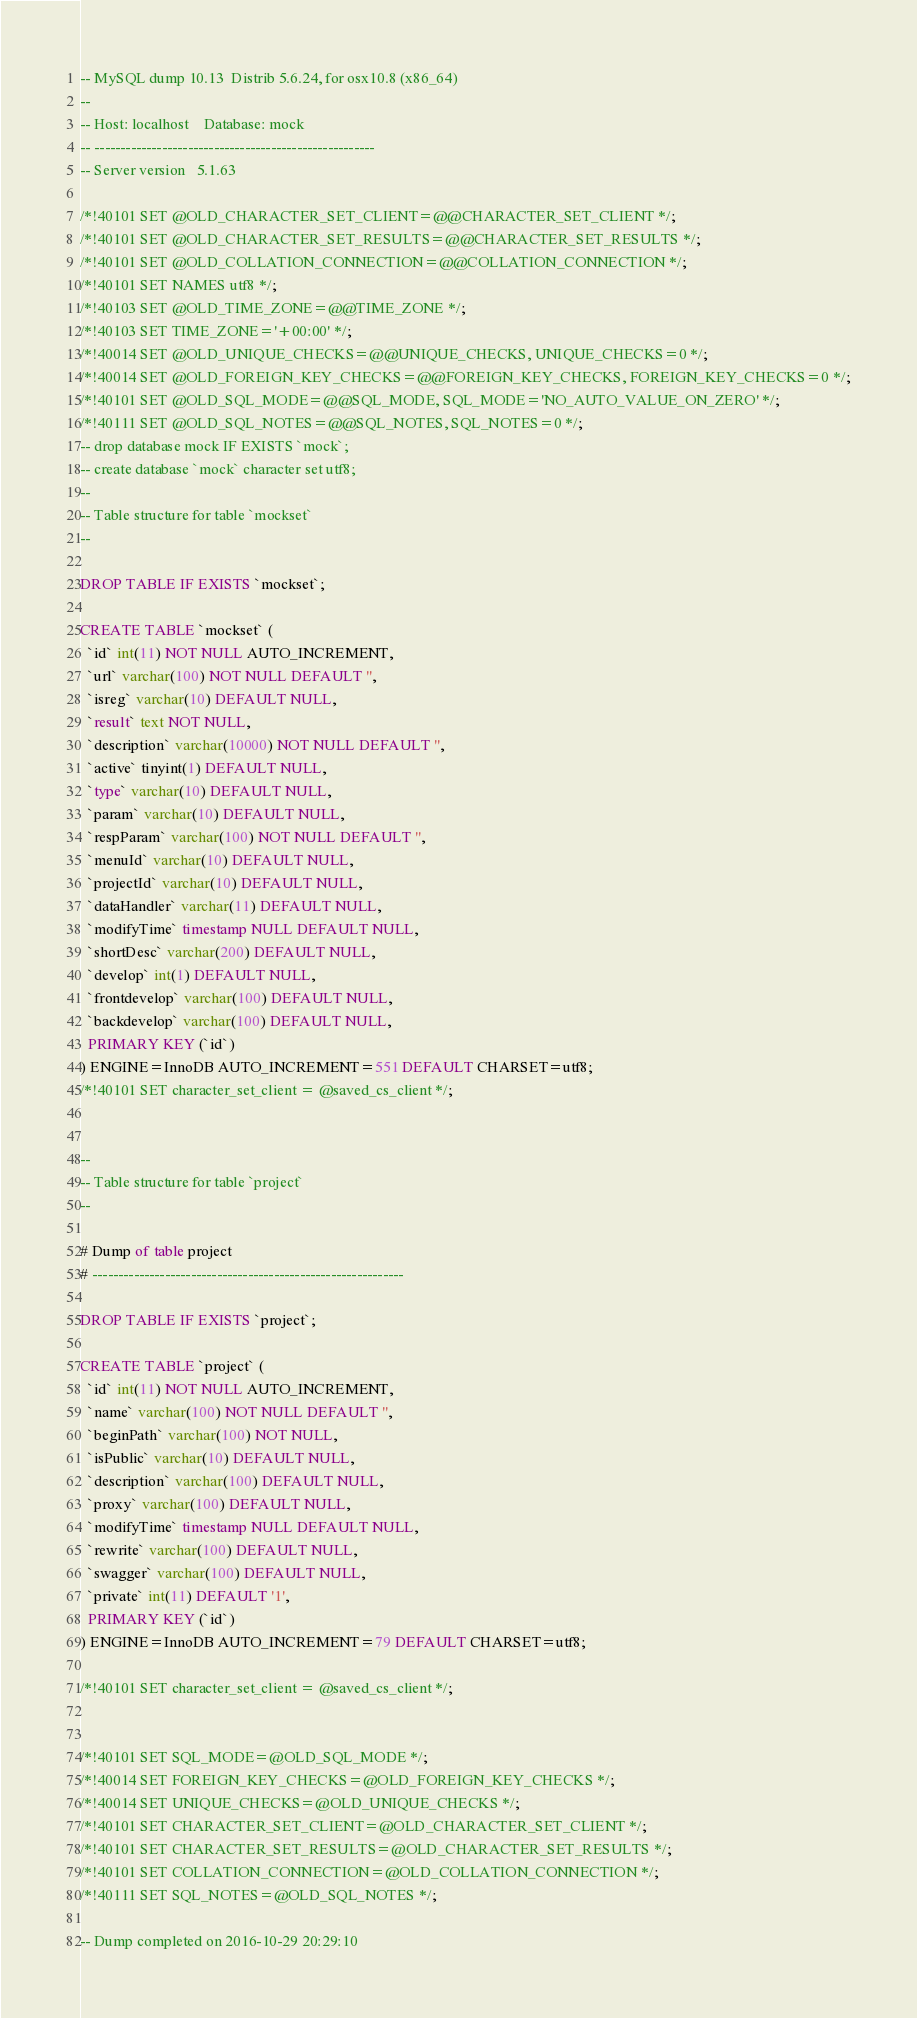<code> <loc_0><loc_0><loc_500><loc_500><_SQL_>-- MySQL dump 10.13  Distrib 5.6.24, for osx10.8 (x86_64)
--
-- Host: localhost    Database: mock
-- ------------------------------------------------------
-- Server version	5.1.63

/*!40101 SET @OLD_CHARACTER_SET_CLIENT=@@CHARACTER_SET_CLIENT */;
/*!40101 SET @OLD_CHARACTER_SET_RESULTS=@@CHARACTER_SET_RESULTS */;
/*!40101 SET @OLD_COLLATION_CONNECTION=@@COLLATION_CONNECTION */;
/*!40101 SET NAMES utf8 */;
/*!40103 SET @OLD_TIME_ZONE=@@TIME_ZONE */;
/*!40103 SET TIME_ZONE='+00:00' */;
/*!40014 SET @OLD_UNIQUE_CHECKS=@@UNIQUE_CHECKS, UNIQUE_CHECKS=0 */;
/*!40014 SET @OLD_FOREIGN_KEY_CHECKS=@@FOREIGN_KEY_CHECKS, FOREIGN_KEY_CHECKS=0 */;
/*!40101 SET @OLD_SQL_MODE=@@SQL_MODE, SQL_MODE='NO_AUTO_VALUE_ON_ZERO' */;
/*!40111 SET @OLD_SQL_NOTES=@@SQL_NOTES, SQL_NOTES=0 */;
-- drop database mock IF EXISTS `mock`;
-- create database `mock` character set utf8;
--
-- Table structure for table `mockset`
--

DROP TABLE IF EXISTS `mockset`;

CREATE TABLE `mockset` (
  `id` int(11) NOT NULL AUTO_INCREMENT,
  `url` varchar(100) NOT NULL DEFAULT '',
  `isreg` varchar(10) DEFAULT NULL,
  `result` text NOT NULL,
  `description` varchar(10000) NOT NULL DEFAULT '',
  `active` tinyint(1) DEFAULT NULL,
  `type` varchar(10) DEFAULT NULL,
  `param` varchar(10) DEFAULT NULL,
  `respParam` varchar(100) NOT NULL DEFAULT '',
  `menuId` varchar(10) DEFAULT NULL,
  `projectId` varchar(10) DEFAULT NULL,
  `dataHandler` varchar(11) DEFAULT NULL,
  `modifyTime` timestamp NULL DEFAULT NULL,
  `shortDesc` varchar(200) DEFAULT NULL,
  `develop` int(1) DEFAULT NULL,
  `frontdevelop` varchar(100) DEFAULT NULL,
  `backdevelop` varchar(100) DEFAULT NULL,
  PRIMARY KEY (`id`)
) ENGINE=InnoDB AUTO_INCREMENT=551 DEFAULT CHARSET=utf8;
/*!40101 SET character_set_client = @saved_cs_client */;


--
-- Table structure for table `project`
--

# Dump of table project
# ------------------------------------------------------------

DROP TABLE IF EXISTS `project`;

CREATE TABLE `project` (
  `id` int(11) NOT NULL AUTO_INCREMENT,
  `name` varchar(100) NOT NULL DEFAULT '',
  `beginPath` varchar(100) NOT NULL,
  `isPublic` varchar(10) DEFAULT NULL,
  `description` varchar(100) DEFAULT NULL,
  `proxy` varchar(100) DEFAULT NULL,
  `modifyTime` timestamp NULL DEFAULT NULL,
  `rewrite` varchar(100) DEFAULT NULL,
  `swagger` varchar(100) DEFAULT NULL,
  `private` int(11) DEFAULT '1',
  PRIMARY KEY (`id`)
) ENGINE=InnoDB AUTO_INCREMENT=79 DEFAULT CHARSET=utf8;

/*!40101 SET character_set_client = @saved_cs_client */;


/*!40101 SET SQL_MODE=@OLD_SQL_MODE */;
/*!40014 SET FOREIGN_KEY_CHECKS=@OLD_FOREIGN_KEY_CHECKS */;
/*!40014 SET UNIQUE_CHECKS=@OLD_UNIQUE_CHECKS */;
/*!40101 SET CHARACTER_SET_CLIENT=@OLD_CHARACTER_SET_CLIENT */;
/*!40101 SET CHARACTER_SET_RESULTS=@OLD_CHARACTER_SET_RESULTS */;
/*!40101 SET COLLATION_CONNECTION=@OLD_COLLATION_CONNECTION */;
/*!40111 SET SQL_NOTES=@OLD_SQL_NOTES */;

-- Dump completed on 2016-10-29 20:29:10
</code> 